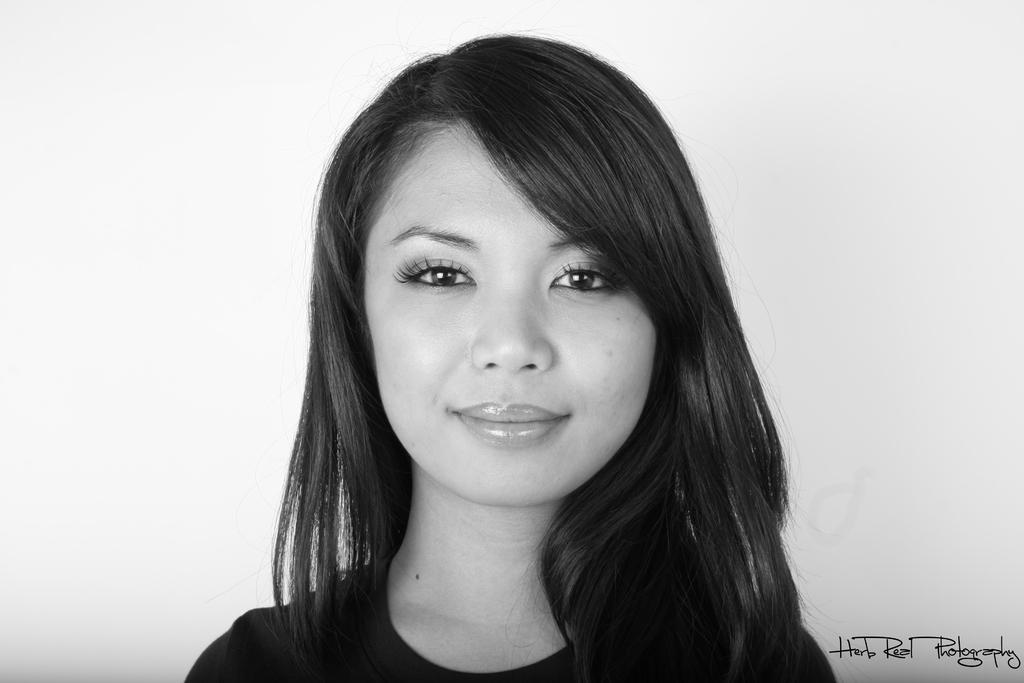Describe this image in one or two sentences. This is a black and white image. In the center of the image there is girl. At the bottom of the image there is text. in the background of the image there is wall. 